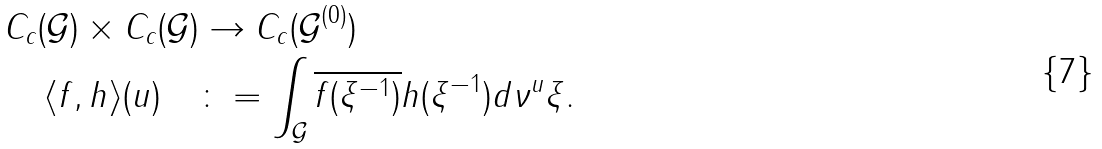<formula> <loc_0><loc_0><loc_500><loc_500>C _ { c } ( \mathcal { G } ) \times C _ { c } ( \mathcal { G } ) & \rightarrow C _ { c } ( \mathcal { G } ^ { ( 0 ) } ) \\ \langle f , h \rangle ( u ) \quad & \colon = \int _ { \mathcal { G } } \overline { f ( \xi ^ { - 1 } ) } h ( \xi ^ { - 1 } ) d \nu ^ { u } \xi .</formula> 